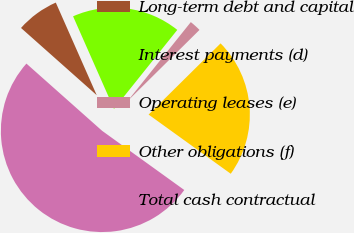Convert chart to OTSL. <chart><loc_0><loc_0><loc_500><loc_500><pie_chart><fcel>Long-term debt and capital<fcel>Interest payments (d)<fcel>Operating leases (e)<fcel>Other obligations (f)<fcel>Total cash contractual<nl><fcel>6.82%<fcel>17.37%<fcel>1.84%<fcel>22.35%<fcel>51.62%<nl></chart> 